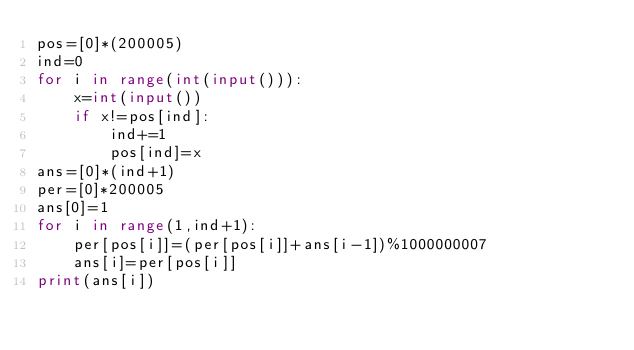Convert code to text. <code><loc_0><loc_0><loc_500><loc_500><_Python_>pos=[0]*(200005)
ind=0
for i in range(int(input())):
	x=int(input())
	if x!=pos[ind]:
		ind+=1
		pos[ind]=x
ans=[0]*(ind+1)
per=[0]*200005
ans[0]=1
for i in range(1,ind+1):
	per[pos[i]]=(per[pos[i]]+ans[i-1])%1000000007
	ans[i]=per[pos[i]]
print(ans[i])</code> 